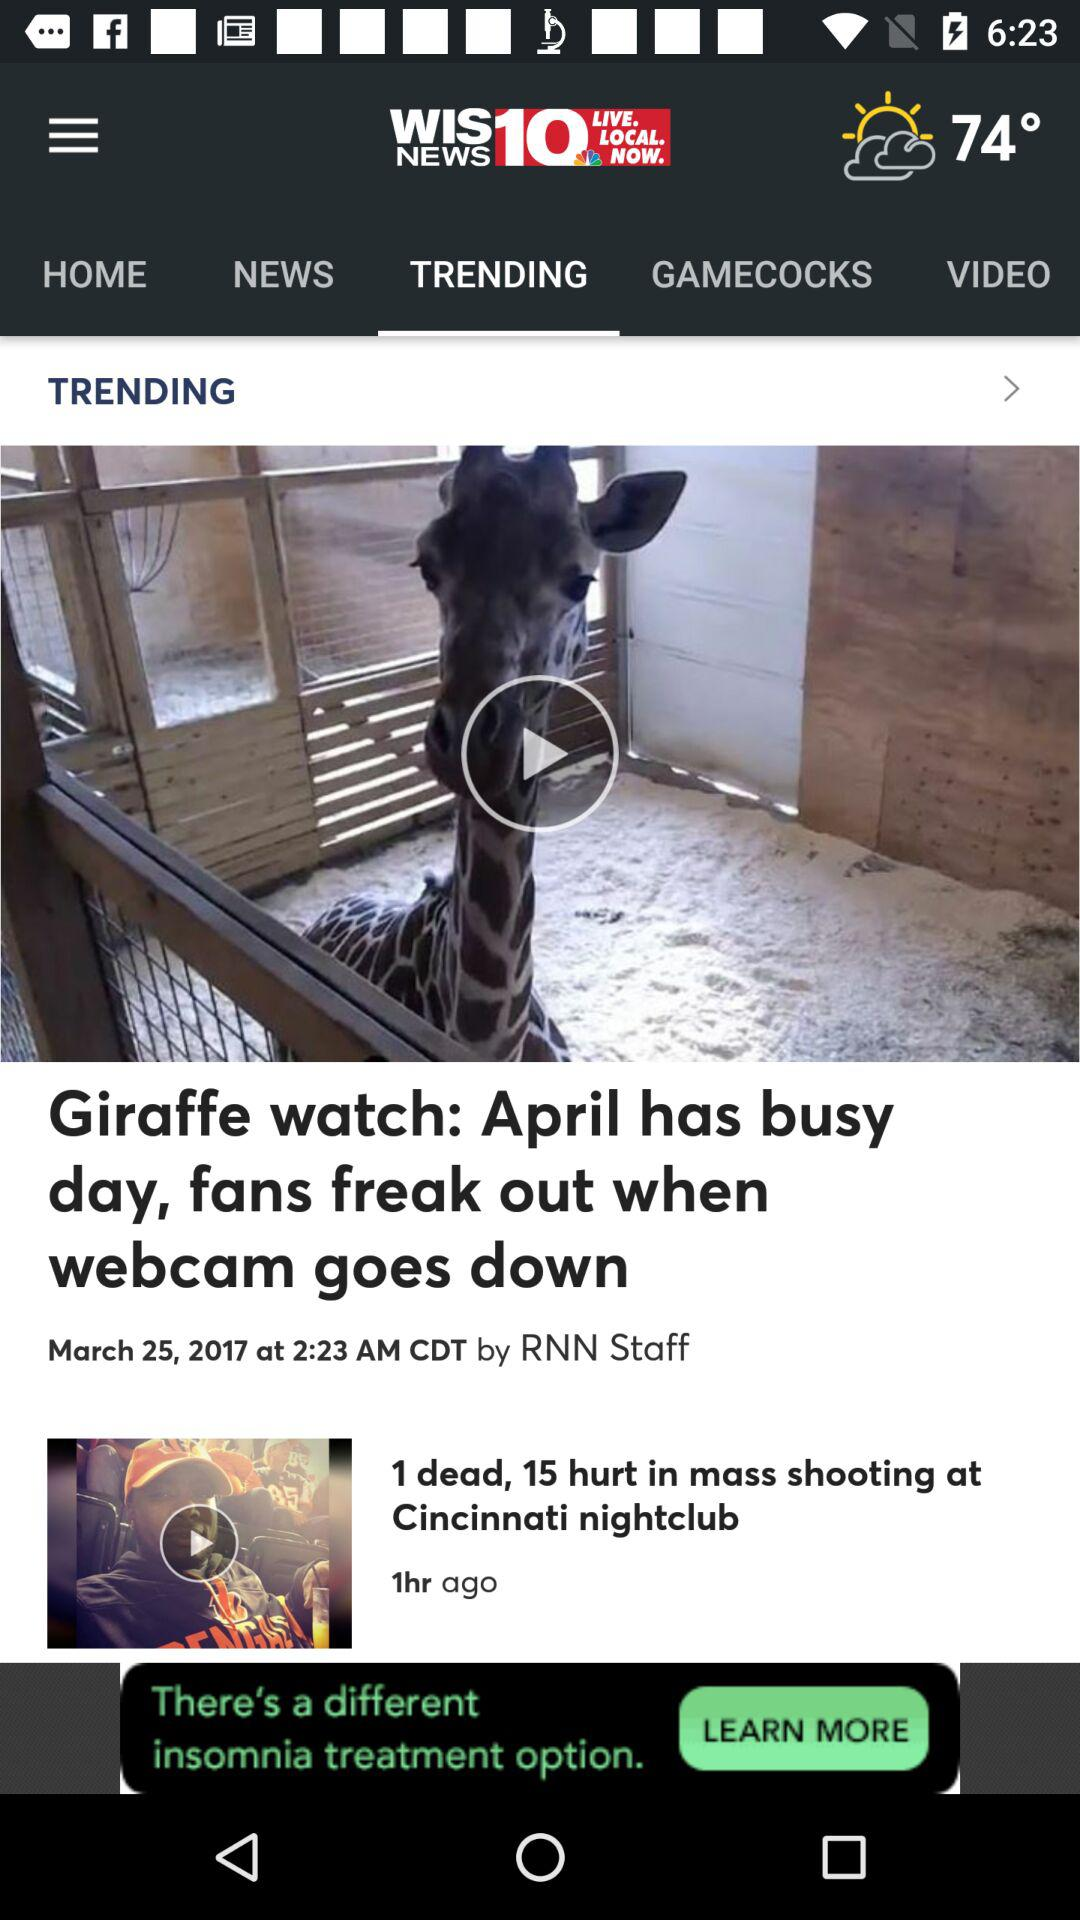What is the name of the news channel? The name of the news channel is "WIS NEWS10". 